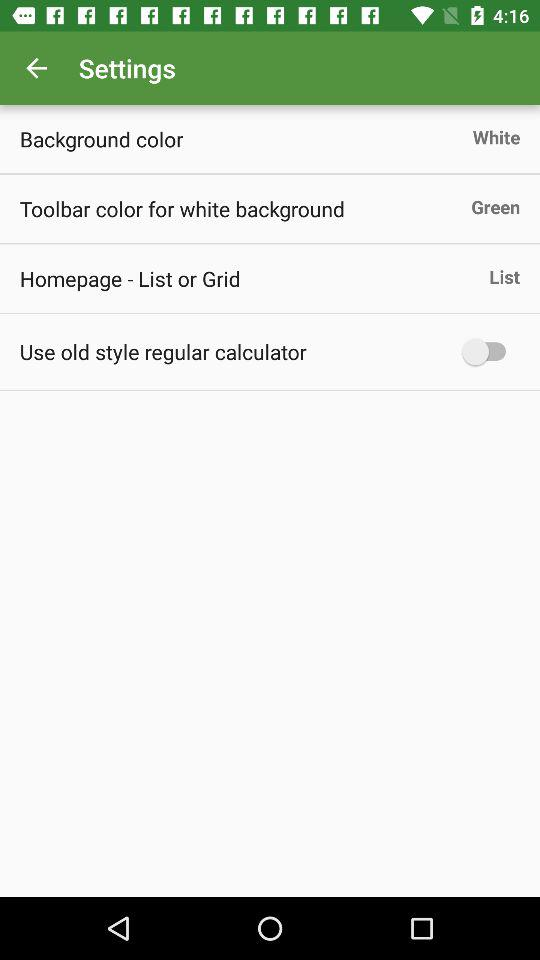What is the status of "Use old style regular calculator"? The status of "Use old style regular calculator" is "off". 